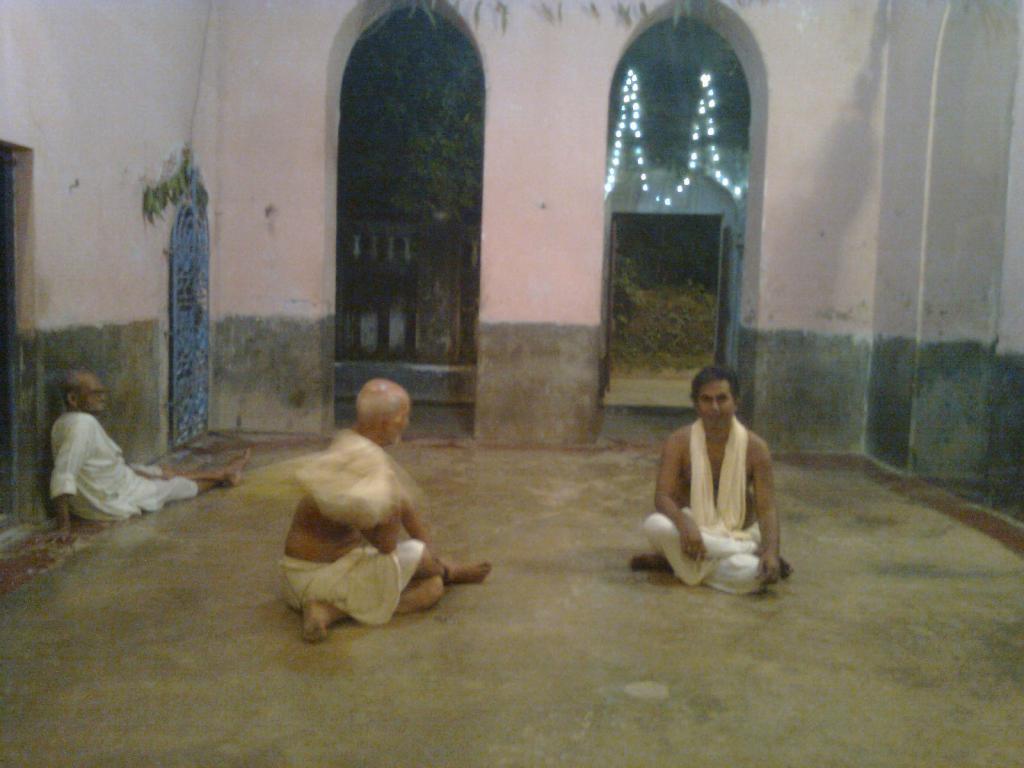In one or two sentences, can you explain what this image depicts? In this image we can see men sitting on the floor, grills, gates, decor lights, trees and plants. 